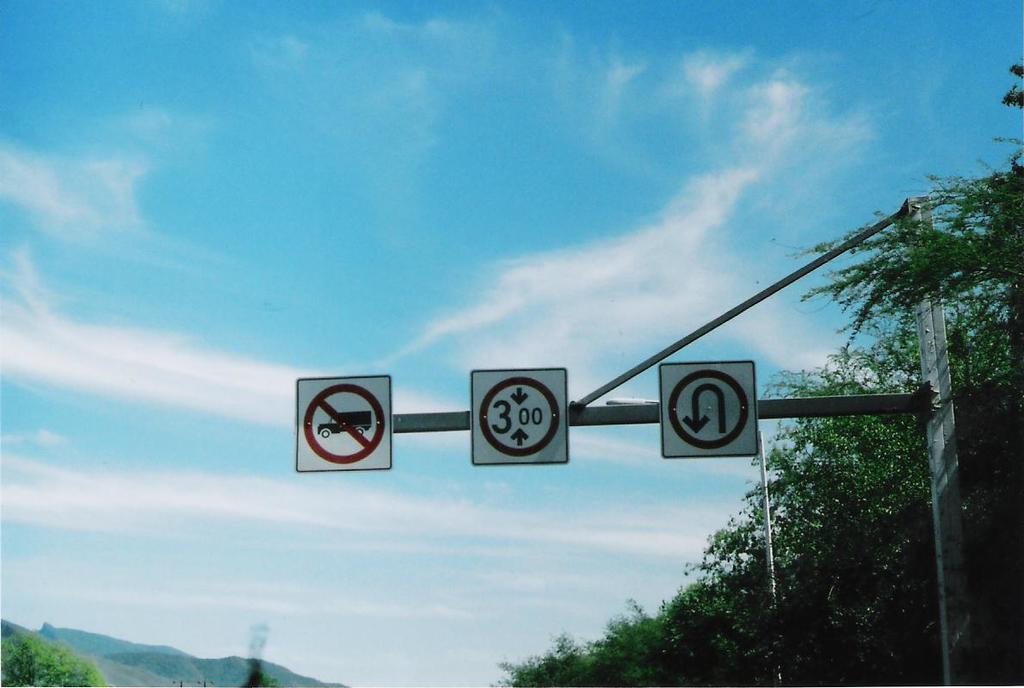<image>
Create a compact narrative representing the image presented. One of the road signs includes the numbers 3,0 and 0 in a circle with arrows. 